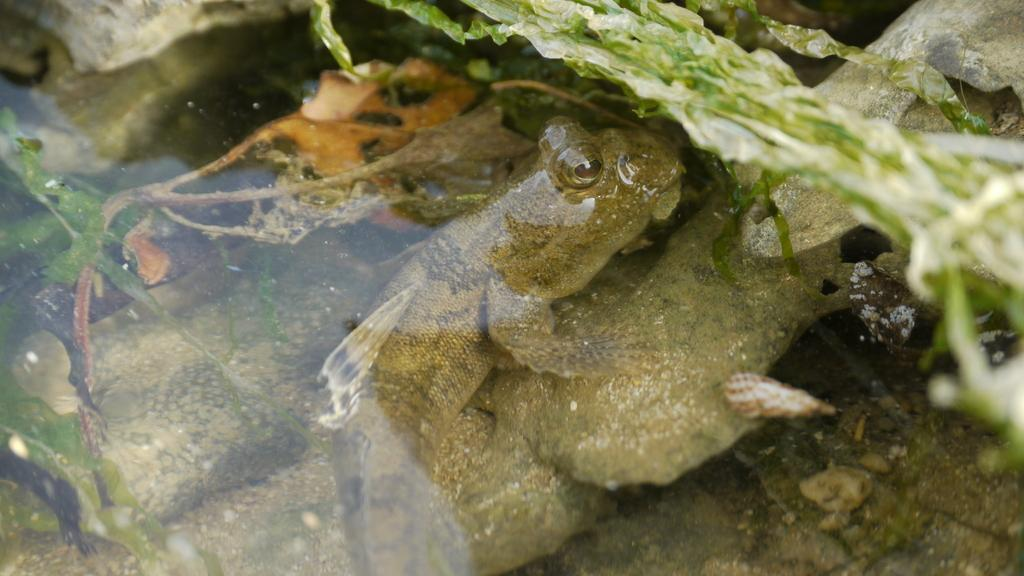What type of animal can be seen in the water in the image? There is a fish inside the water in the image. What other elements can be seen in the image besides the fish? Few leaves and stones are visible in the image. What type of error can be seen in the image? There is no error present in the image; it is a clear depiction of a fish in water, leaves, and stones. 